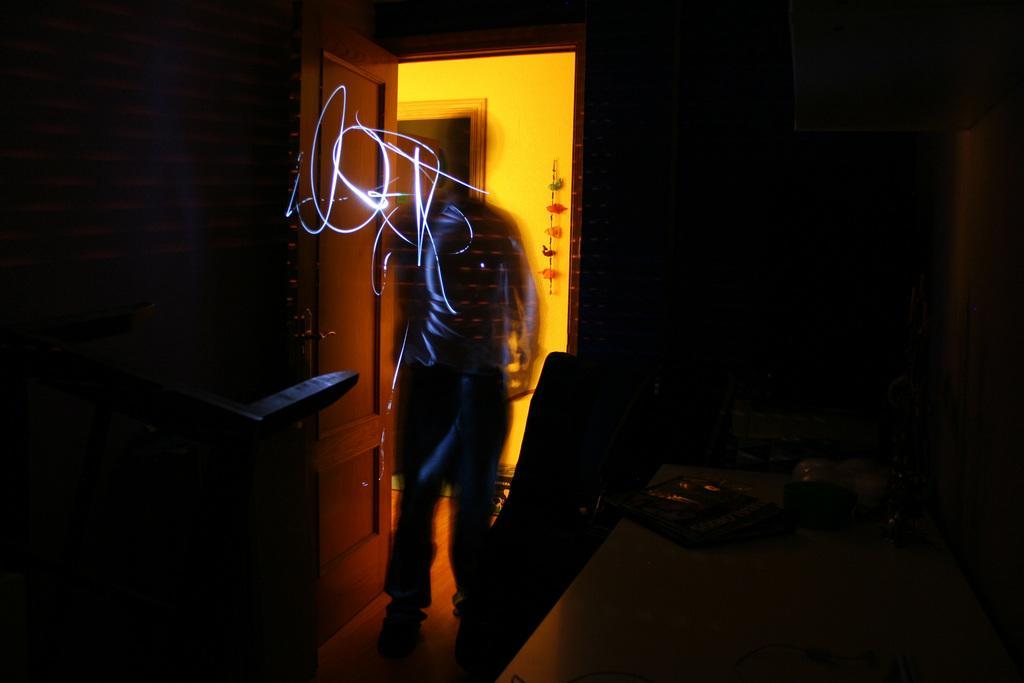Please provide a concise description of this image. In this picture I can see a person who is standing in the centre and I see the light and I see that it is dark on both the sides. In the background I see the wall and I see a door near to the person. 